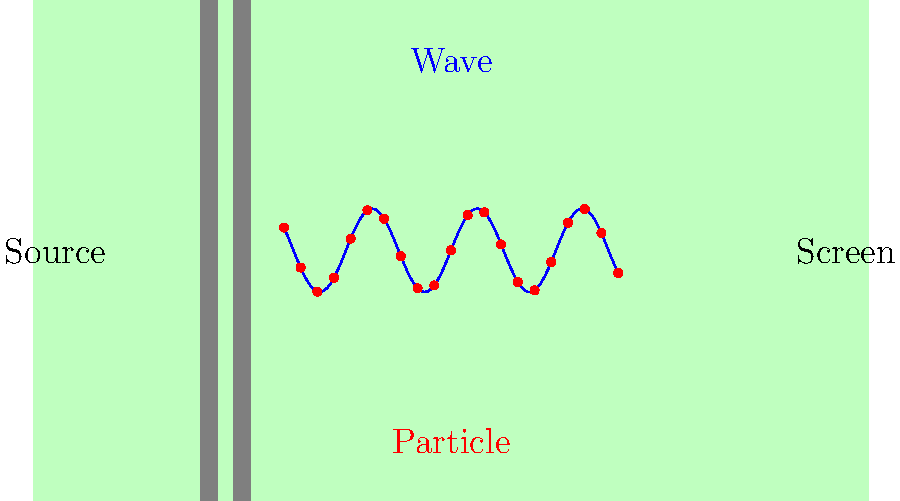In the abstract representation of the double-slit experiment shown, how does the visualization challenge our conventional understanding of matter, and what artistic interpretation could be drawn from this paradoxical nature of quantum entities? 1. The double-slit experiment, represented abstractly here, demonstrates the wave-particle duality of quantum entities.

2. The blue sinusoidal curve represents the wave-like behavior of particles, showing interference patterns typical of waves passing through two slits.

3. The red dots represent the particle-like behavior, where individual particles are detected on the screen.

4. This simultaneous display of wave and particle properties challenges our classical understanding of matter as being either exclusively particles or waves.

5. The green background symbolizes the quantum realm, where our classical intuitions break down.

6. From an artistic perspective, this visualization can be interpreted as a representation of duality and complementarity in nature.

7. The abstract nature of the diagram aligns with the concept that quantum mechanics defies concrete, classical visualization.

8. The interplay between the continuous wave and discrete particles can be seen as a metaphor for the tension between continuity and discreteness in art and design.

9. The symmetry of the pattern suggests an underlying order in apparent randomness, a common theme in abstract art.

10. The paradoxical nature of quantum entities, being both wave and particle simultaneously, mirrors the often contradictory nature of abstract art, which can convey multiple, sometimes conflicting, interpretations.
Answer: Wave-particle duality paradox as abstract art metaphor 